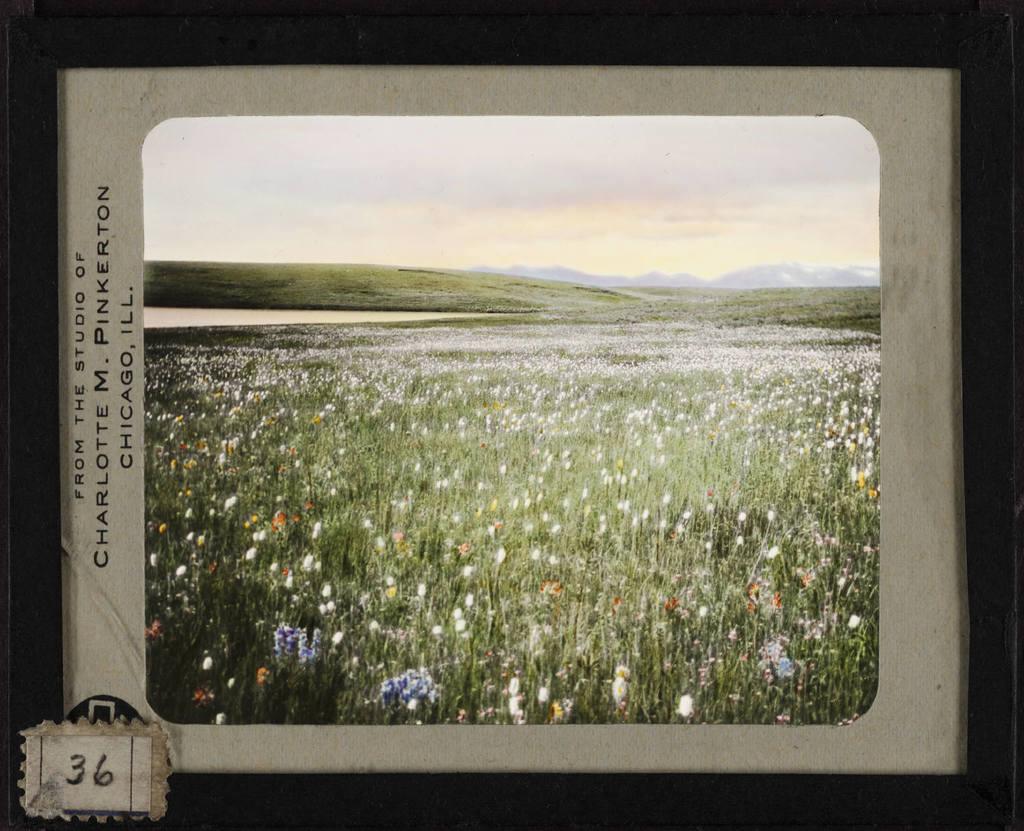Whaos name is on theis photo?
Your response must be concise. Charlotte m. pinkerton. What number is in the bottom left corner?
Ensure brevity in your answer.  36. 